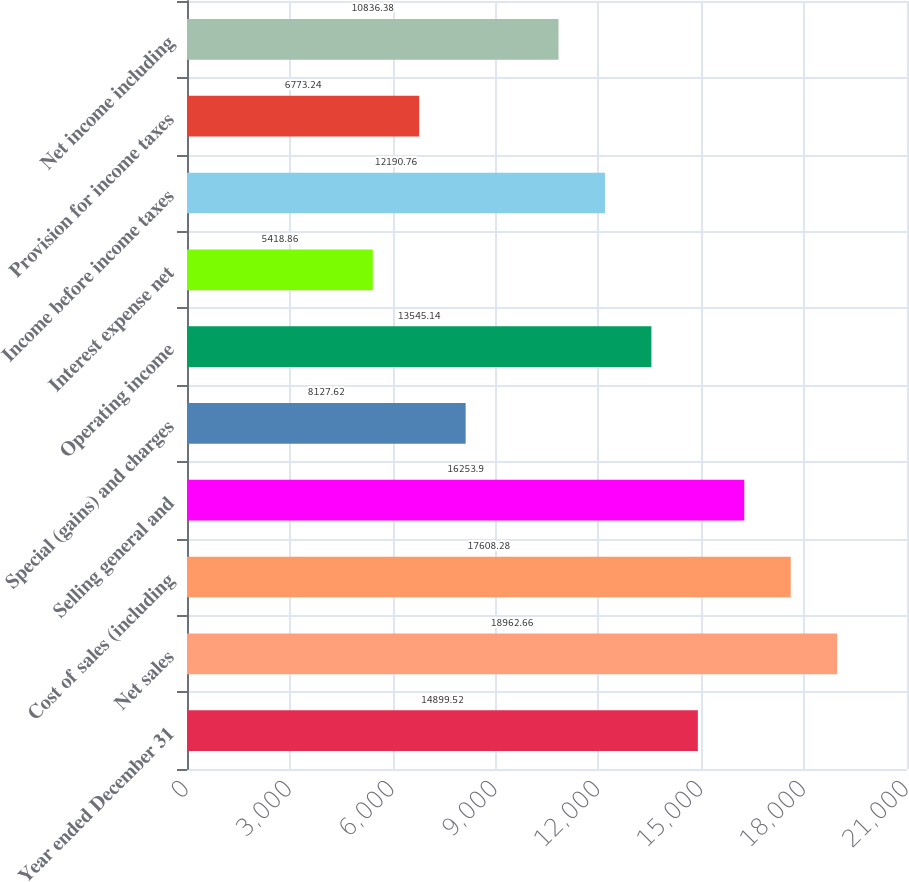Convert chart to OTSL. <chart><loc_0><loc_0><loc_500><loc_500><bar_chart><fcel>Year ended December 31<fcel>Net sales<fcel>Cost of sales (including<fcel>Selling general and<fcel>Special (gains) and charges<fcel>Operating income<fcel>Interest expense net<fcel>Income before income taxes<fcel>Provision for income taxes<fcel>Net income including<nl><fcel>14899.5<fcel>18962.7<fcel>17608.3<fcel>16253.9<fcel>8127.62<fcel>13545.1<fcel>5418.86<fcel>12190.8<fcel>6773.24<fcel>10836.4<nl></chart> 